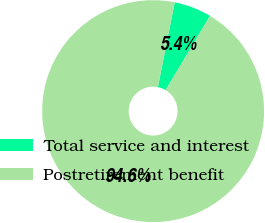<chart> <loc_0><loc_0><loc_500><loc_500><pie_chart><fcel>Total service and interest<fcel>Postretirement benefit<nl><fcel>5.45%<fcel>94.55%<nl></chart> 